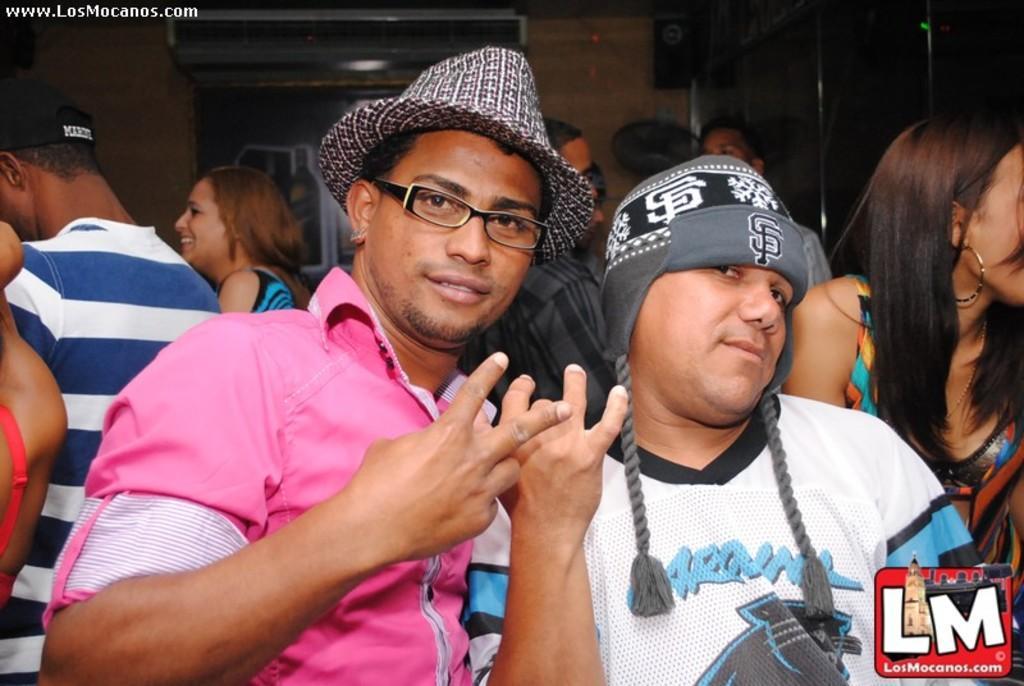How would you summarize this image in a sentence or two? This image consists of two persons standing in the front. On the left, the man is wearing a pink shirt and a hat. In the background, there are many people. And we can see a wall. 